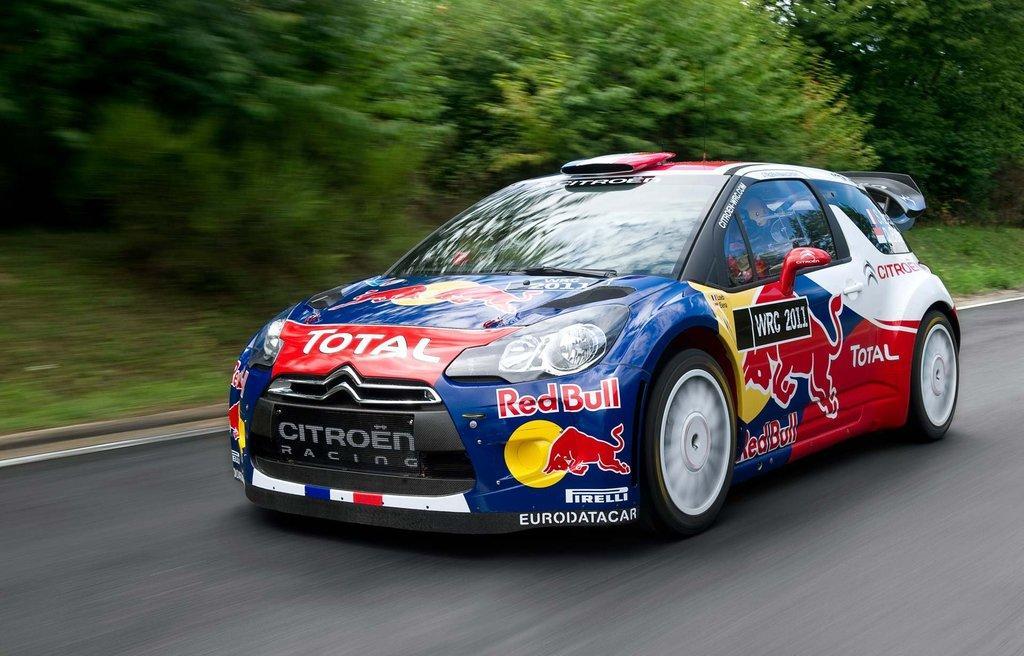Can you describe this image briefly? In the picture I can see a racing car on the road. In the background, I can see the trees. 